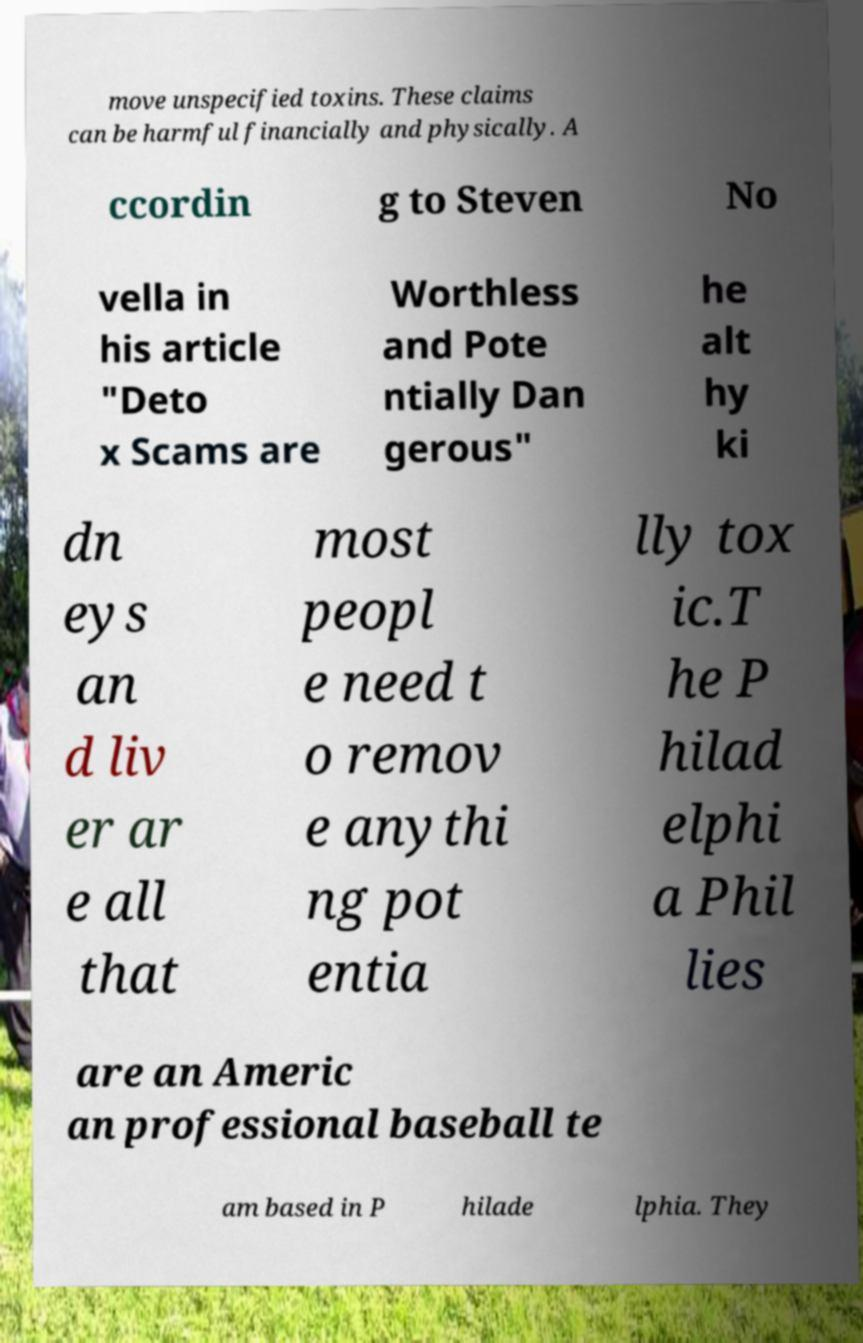What messages or text are displayed in this image? I need them in a readable, typed format. move unspecified toxins. These claims can be harmful financially and physically. A ccordin g to Steven No vella in his article "Deto x Scams are Worthless and Pote ntially Dan gerous" he alt hy ki dn eys an d liv er ar e all that most peopl e need t o remov e anythi ng pot entia lly tox ic.T he P hilad elphi a Phil lies are an Americ an professional baseball te am based in P hilade lphia. They 